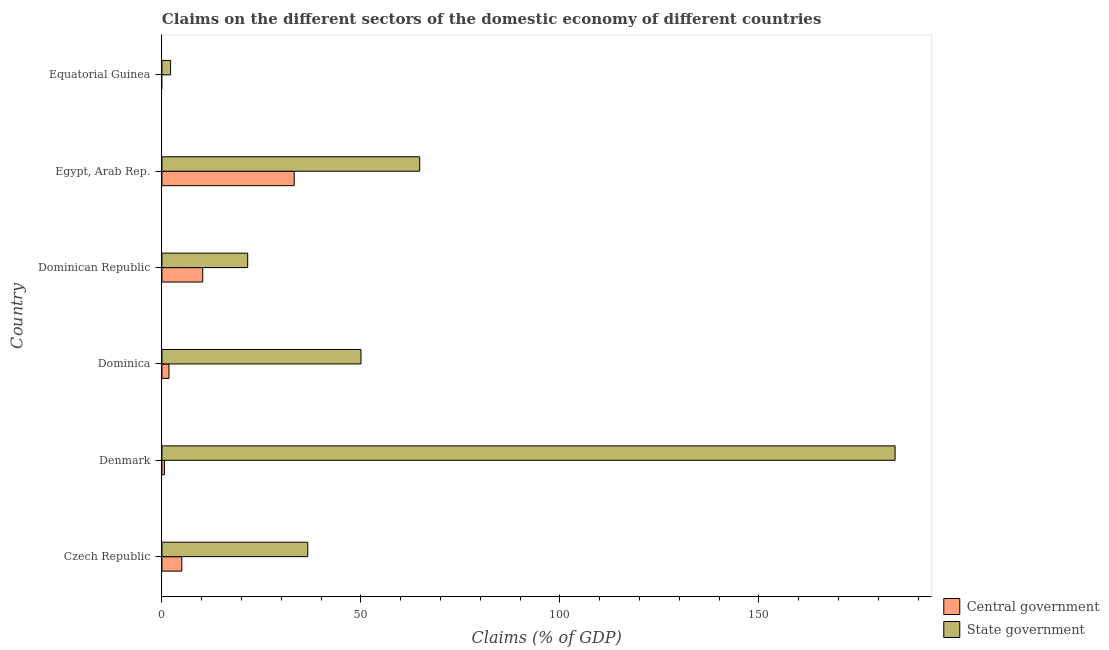Are the number of bars per tick equal to the number of legend labels?
Provide a short and direct response. No. How many bars are there on the 1st tick from the top?
Provide a short and direct response. 1. How many bars are there on the 5th tick from the bottom?
Your answer should be very brief. 2. What is the label of the 4th group of bars from the top?
Keep it short and to the point. Dominica. In how many cases, is the number of bars for a given country not equal to the number of legend labels?
Offer a terse response. 1. What is the claims on state government in Equatorial Guinea?
Provide a succinct answer. 2.18. Across all countries, what is the maximum claims on state government?
Your answer should be compact. 184.22. Across all countries, what is the minimum claims on state government?
Offer a terse response. 2.18. In which country was the claims on central government maximum?
Provide a short and direct response. Egypt, Arab Rep. What is the total claims on central government in the graph?
Offer a terse response. 50.92. What is the difference between the claims on state government in Czech Republic and that in Dominican Republic?
Offer a terse response. 15.1. What is the difference between the claims on state government in Czech Republic and the claims on central government in Dominica?
Your answer should be compact. 34.87. What is the average claims on state government per country?
Your answer should be compact. 59.9. What is the difference between the claims on state government and claims on central government in Egypt, Arab Rep.?
Make the answer very short. 31.53. What is the ratio of the claims on central government in Dominican Republic to that in Egypt, Arab Rep.?
Give a very brief answer. 0.31. What is the difference between the highest and the second highest claims on central government?
Ensure brevity in your answer.  22.99. What is the difference between the highest and the lowest claims on central government?
Your answer should be compact. 33.25. Are the values on the major ticks of X-axis written in scientific E-notation?
Your response must be concise. No. Does the graph contain grids?
Ensure brevity in your answer.  No. What is the title of the graph?
Your answer should be compact. Claims on the different sectors of the domestic economy of different countries. Does "Drinking water services" appear as one of the legend labels in the graph?
Ensure brevity in your answer.  No. What is the label or title of the X-axis?
Offer a terse response. Claims (% of GDP). What is the Claims (% of GDP) in Central government in Czech Republic?
Ensure brevity in your answer.  5. What is the Claims (% of GDP) in State government in Czech Republic?
Make the answer very short. 36.65. What is the Claims (% of GDP) in Central government in Denmark?
Keep it short and to the point. 0.64. What is the Claims (% of GDP) of State government in Denmark?
Offer a very short reply. 184.22. What is the Claims (% of GDP) of Central government in Dominica?
Your response must be concise. 1.78. What is the Claims (% of GDP) of State government in Dominica?
Make the answer very short. 50.02. What is the Claims (% of GDP) of Central government in Dominican Republic?
Keep it short and to the point. 10.26. What is the Claims (% of GDP) of State government in Dominican Republic?
Your response must be concise. 21.56. What is the Claims (% of GDP) in Central government in Egypt, Arab Rep.?
Offer a terse response. 33.25. What is the Claims (% of GDP) of State government in Egypt, Arab Rep.?
Ensure brevity in your answer.  64.77. What is the Claims (% of GDP) in State government in Equatorial Guinea?
Ensure brevity in your answer.  2.18. Across all countries, what is the maximum Claims (% of GDP) in Central government?
Give a very brief answer. 33.25. Across all countries, what is the maximum Claims (% of GDP) in State government?
Your response must be concise. 184.22. Across all countries, what is the minimum Claims (% of GDP) of State government?
Give a very brief answer. 2.18. What is the total Claims (% of GDP) in Central government in the graph?
Your answer should be very brief. 50.92. What is the total Claims (% of GDP) of State government in the graph?
Make the answer very short. 359.41. What is the difference between the Claims (% of GDP) in Central government in Czech Republic and that in Denmark?
Your answer should be compact. 4.37. What is the difference between the Claims (% of GDP) of State government in Czech Republic and that in Denmark?
Give a very brief answer. -147.56. What is the difference between the Claims (% of GDP) in Central government in Czech Republic and that in Dominica?
Keep it short and to the point. 3.23. What is the difference between the Claims (% of GDP) in State government in Czech Republic and that in Dominica?
Your answer should be compact. -13.37. What is the difference between the Claims (% of GDP) in Central government in Czech Republic and that in Dominican Republic?
Give a very brief answer. -5.25. What is the difference between the Claims (% of GDP) in State government in Czech Republic and that in Dominican Republic?
Your response must be concise. 15.1. What is the difference between the Claims (% of GDP) in Central government in Czech Republic and that in Egypt, Arab Rep.?
Offer a very short reply. -28.24. What is the difference between the Claims (% of GDP) of State government in Czech Republic and that in Egypt, Arab Rep.?
Keep it short and to the point. -28.12. What is the difference between the Claims (% of GDP) in State government in Czech Republic and that in Equatorial Guinea?
Provide a short and direct response. 34.47. What is the difference between the Claims (% of GDP) of Central government in Denmark and that in Dominica?
Offer a terse response. -1.14. What is the difference between the Claims (% of GDP) of State government in Denmark and that in Dominica?
Ensure brevity in your answer.  134.19. What is the difference between the Claims (% of GDP) of Central government in Denmark and that in Dominican Republic?
Ensure brevity in your answer.  -9.62. What is the difference between the Claims (% of GDP) of State government in Denmark and that in Dominican Republic?
Keep it short and to the point. 162.66. What is the difference between the Claims (% of GDP) in Central government in Denmark and that in Egypt, Arab Rep.?
Keep it short and to the point. -32.61. What is the difference between the Claims (% of GDP) in State government in Denmark and that in Egypt, Arab Rep.?
Offer a very short reply. 119.44. What is the difference between the Claims (% of GDP) of State government in Denmark and that in Equatorial Guinea?
Your answer should be compact. 182.04. What is the difference between the Claims (% of GDP) of Central government in Dominica and that in Dominican Republic?
Keep it short and to the point. -8.48. What is the difference between the Claims (% of GDP) of State government in Dominica and that in Dominican Republic?
Offer a terse response. 28.47. What is the difference between the Claims (% of GDP) in Central government in Dominica and that in Egypt, Arab Rep.?
Ensure brevity in your answer.  -31.47. What is the difference between the Claims (% of GDP) in State government in Dominica and that in Egypt, Arab Rep.?
Ensure brevity in your answer.  -14.75. What is the difference between the Claims (% of GDP) of State government in Dominica and that in Equatorial Guinea?
Offer a very short reply. 47.84. What is the difference between the Claims (% of GDP) in Central government in Dominican Republic and that in Egypt, Arab Rep.?
Your answer should be very brief. -22.99. What is the difference between the Claims (% of GDP) in State government in Dominican Republic and that in Egypt, Arab Rep.?
Your answer should be compact. -43.22. What is the difference between the Claims (% of GDP) of State government in Dominican Republic and that in Equatorial Guinea?
Offer a very short reply. 19.37. What is the difference between the Claims (% of GDP) in State government in Egypt, Arab Rep. and that in Equatorial Guinea?
Your answer should be compact. 62.59. What is the difference between the Claims (% of GDP) of Central government in Czech Republic and the Claims (% of GDP) of State government in Denmark?
Your answer should be very brief. -179.21. What is the difference between the Claims (% of GDP) in Central government in Czech Republic and the Claims (% of GDP) in State government in Dominica?
Give a very brief answer. -45.02. What is the difference between the Claims (% of GDP) in Central government in Czech Republic and the Claims (% of GDP) in State government in Dominican Republic?
Your response must be concise. -16.55. What is the difference between the Claims (% of GDP) in Central government in Czech Republic and the Claims (% of GDP) in State government in Egypt, Arab Rep.?
Your response must be concise. -59.77. What is the difference between the Claims (% of GDP) in Central government in Czech Republic and the Claims (% of GDP) in State government in Equatorial Guinea?
Your response must be concise. 2.82. What is the difference between the Claims (% of GDP) of Central government in Denmark and the Claims (% of GDP) of State government in Dominica?
Make the answer very short. -49.39. What is the difference between the Claims (% of GDP) in Central government in Denmark and the Claims (% of GDP) in State government in Dominican Republic?
Offer a terse response. -20.92. What is the difference between the Claims (% of GDP) of Central government in Denmark and the Claims (% of GDP) of State government in Egypt, Arab Rep.?
Make the answer very short. -64.14. What is the difference between the Claims (% of GDP) in Central government in Denmark and the Claims (% of GDP) in State government in Equatorial Guinea?
Give a very brief answer. -1.55. What is the difference between the Claims (% of GDP) in Central government in Dominica and the Claims (% of GDP) in State government in Dominican Republic?
Provide a short and direct response. -19.78. What is the difference between the Claims (% of GDP) of Central government in Dominica and the Claims (% of GDP) of State government in Egypt, Arab Rep.?
Make the answer very short. -63. What is the difference between the Claims (% of GDP) in Central government in Dominica and the Claims (% of GDP) in State government in Equatorial Guinea?
Provide a short and direct response. -0.4. What is the difference between the Claims (% of GDP) in Central government in Dominican Republic and the Claims (% of GDP) in State government in Egypt, Arab Rep.?
Make the answer very short. -54.51. What is the difference between the Claims (% of GDP) in Central government in Dominican Republic and the Claims (% of GDP) in State government in Equatorial Guinea?
Make the answer very short. 8.08. What is the difference between the Claims (% of GDP) of Central government in Egypt, Arab Rep. and the Claims (% of GDP) of State government in Equatorial Guinea?
Provide a succinct answer. 31.06. What is the average Claims (% of GDP) of Central government per country?
Provide a succinct answer. 8.49. What is the average Claims (% of GDP) of State government per country?
Keep it short and to the point. 59.9. What is the difference between the Claims (% of GDP) in Central government and Claims (% of GDP) in State government in Czech Republic?
Provide a short and direct response. -31.65. What is the difference between the Claims (% of GDP) in Central government and Claims (% of GDP) in State government in Denmark?
Provide a succinct answer. -183.58. What is the difference between the Claims (% of GDP) in Central government and Claims (% of GDP) in State government in Dominica?
Offer a very short reply. -48.25. What is the difference between the Claims (% of GDP) of Central government and Claims (% of GDP) of State government in Dominican Republic?
Offer a terse response. -11.3. What is the difference between the Claims (% of GDP) of Central government and Claims (% of GDP) of State government in Egypt, Arab Rep.?
Provide a short and direct response. -31.53. What is the ratio of the Claims (% of GDP) in Central government in Czech Republic to that in Denmark?
Your response must be concise. 7.88. What is the ratio of the Claims (% of GDP) of State government in Czech Republic to that in Denmark?
Your response must be concise. 0.2. What is the ratio of the Claims (% of GDP) in Central government in Czech Republic to that in Dominica?
Offer a very short reply. 2.81. What is the ratio of the Claims (% of GDP) of State government in Czech Republic to that in Dominica?
Provide a short and direct response. 0.73. What is the ratio of the Claims (% of GDP) in Central government in Czech Republic to that in Dominican Republic?
Your response must be concise. 0.49. What is the ratio of the Claims (% of GDP) of State government in Czech Republic to that in Dominican Republic?
Provide a succinct answer. 1.7. What is the ratio of the Claims (% of GDP) in Central government in Czech Republic to that in Egypt, Arab Rep.?
Provide a succinct answer. 0.15. What is the ratio of the Claims (% of GDP) in State government in Czech Republic to that in Egypt, Arab Rep.?
Offer a very short reply. 0.57. What is the ratio of the Claims (% of GDP) of State government in Czech Republic to that in Equatorial Guinea?
Give a very brief answer. 16.8. What is the ratio of the Claims (% of GDP) in Central government in Denmark to that in Dominica?
Keep it short and to the point. 0.36. What is the ratio of the Claims (% of GDP) in State government in Denmark to that in Dominica?
Make the answer very short. 3.68. What is the ratio of the Claims (% of GDP) in Central government in Denmark to that in Dominican Republic?
Your answer should be very brief. 0.06. What is the ratio of the Claims (% of GDP) in State government in Denmark to that in Dominican Republic?
Your response must be concise. 8.55. What is the ratio of the Claims (% of GDP) of Central government in Denmark to that in Egypt, Arab Rep.?
Make the answer very short. 0.02. What is the ratio of the Claims (% of GDP) of State government in Denmark to that in Egypt, Arab Rep.?
Make the answer very short. 2.84. What is the ratio of the Claims (% of GDP) of State government in Denmark to that in Equatorial Guinea?
Your response must be concise. 84.42. What is the ratio of the Claims (% of GDP) in Central government in Dominica to that in Dominican Republic?
Give a very brief answer. 0.17. What is the ratio of the Claims (% of GDP) in State government in Dominica to that in Dominican Republic?
Offer a terse response. 2.32. What is the ratio of the Claims (% of GDP) of Central government in Dominica to that in Egypt, Arab Rep.?
Your answer should be very brief. 0.05. What is the ratio of the Claims (% of GDP) in State government in Dominica to that in Egypt, Arab Rep.?
Make the answer very short. 0.77. What is the ratio of the Claims (% of GDP) of State government in Dominica to that in Equatorial Guinea?
Offer a terse response. 22.92. What is the ratio of the Claims (% of GDP) of Central government in Dominican Republic to that in Egypt, Arab Rep.?
Provide a short and direct response. 0.31. What is the ratio of the Claims (% of GDP) in State government in Dominican Republic to that in Egypt, Arab Rep.?
Provide a succinct answer. 0.33. What is the ratio of the Claims (% of GDP) in State government in Dominican Republic to that in Equatorial Guinea?
Provide a short and direct response. 9.88. What is the ratio of the Claims (% of GDP) in State government in Egypt, Arab Rep. to that in Equatorial Guinea?
Ensure brevity in your answer.  29.68. What is the difference between the highest and the second highest Claims (% of GDP) in Central government?
Provide a short and direct response. 22.99. What is the difference between the highest and the second highest Claims (% of GDP) in State government?
Keep it short and to the point. 119.44. What is the difference between the highest and the lowest Claims (% of GDP) of Central government?
Keep it short and to the point. 33.25. What is the difference between the highest and the lowest Claims (% of GDP) of State government?
Offer a very short reply. 182.04. 